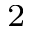<formula> <loc_0><loc_0><loc_500><loc_500>^ { 2 }</formula> 